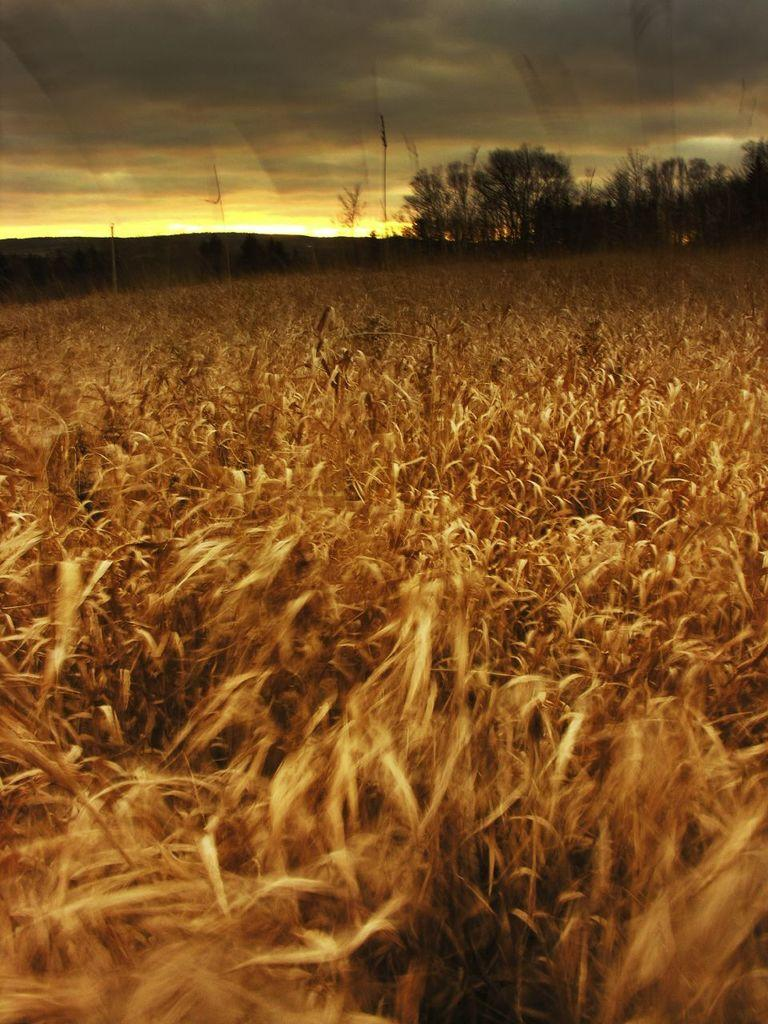What is located in the foreground of the image? There is a crop in the foreground of the image. What can be seen in the background of the image? There are trees and mountains in the background of the image. What is visible in the sky in the image? The sky is visible in the background of the image. Can you see a cat playing with a heart-shaped balloon in the image? There is no cat or heart-shaped balloon present in the image. Is there a zebra grazing in the crop in the foreground of the image? There is no zebra present in the image; it features a crop in the foreground. 